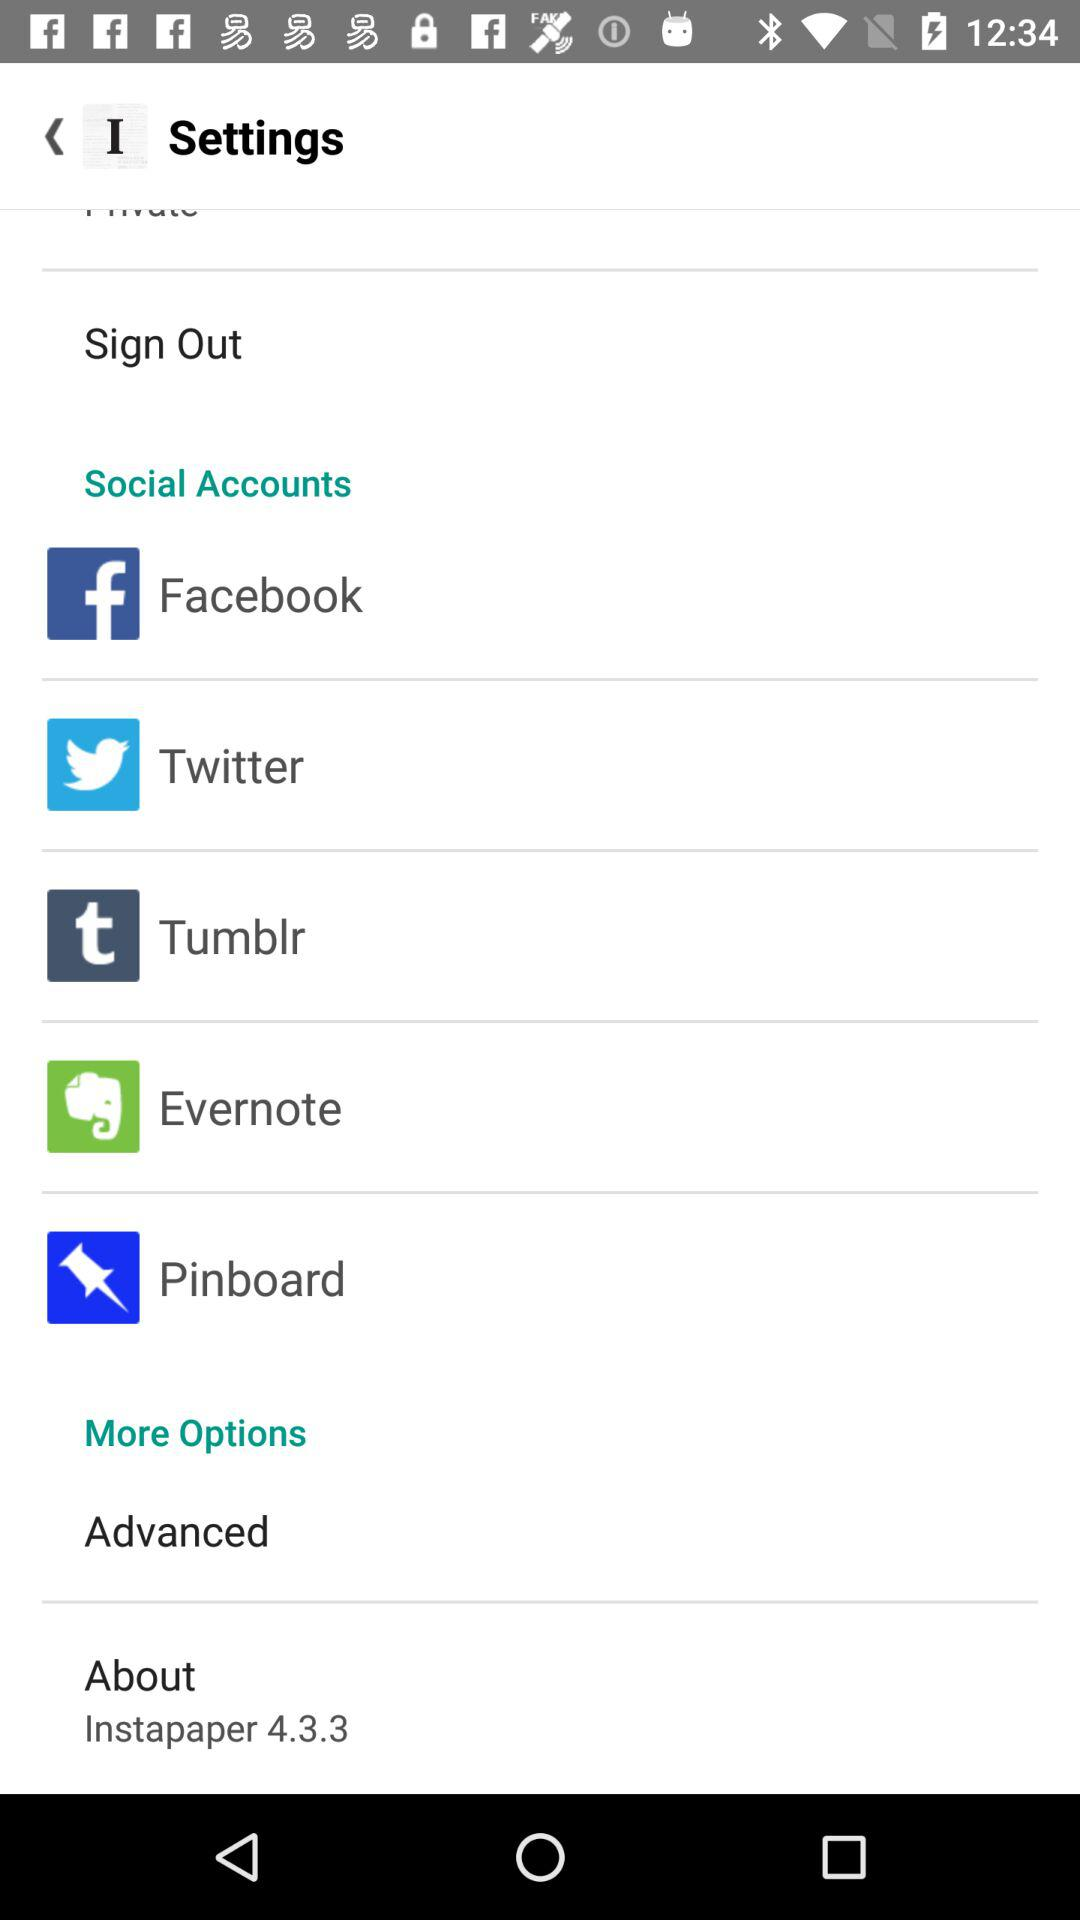What is the version? The version is 4.3.3. 